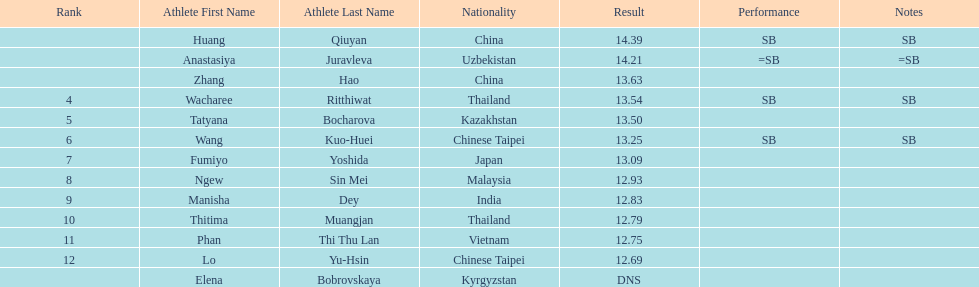How many contestants were from thailand? 2. 